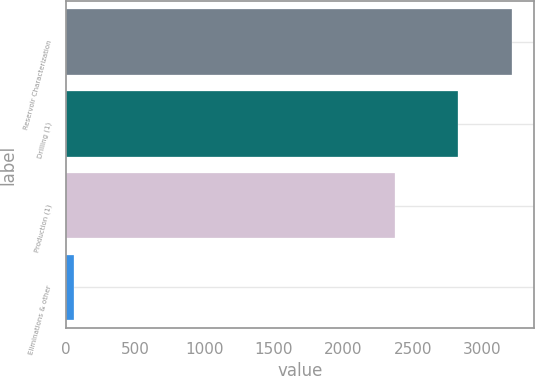Convert chart to OTSL. <chart><loc_0><loc_0><loc_500><loc_500><bar_chart><fcel>Reservoir Characterization<fcel>Drilling (1)<fcel>Production (1)<fcel>Eliminations & other<nl><fcel>3212<fcel>2824<fcel>2371<fcel>60<nl></chart> 